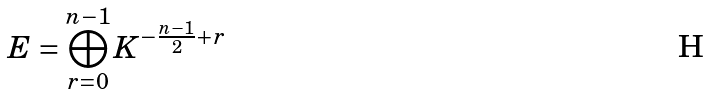<formula> <loc_0><loc_0><loc_500><loc_500>E = \bigoplus _ { r = 0 } ^ { n - 1 } K ^ { - \frac { n - 1 } { 2 } + r }</formula> 